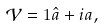<formula> <loc_0><loc_0><loc_500><loc_500>\mathcal { V } = { 1 } \hat { a } + { i } a ,</formula> 